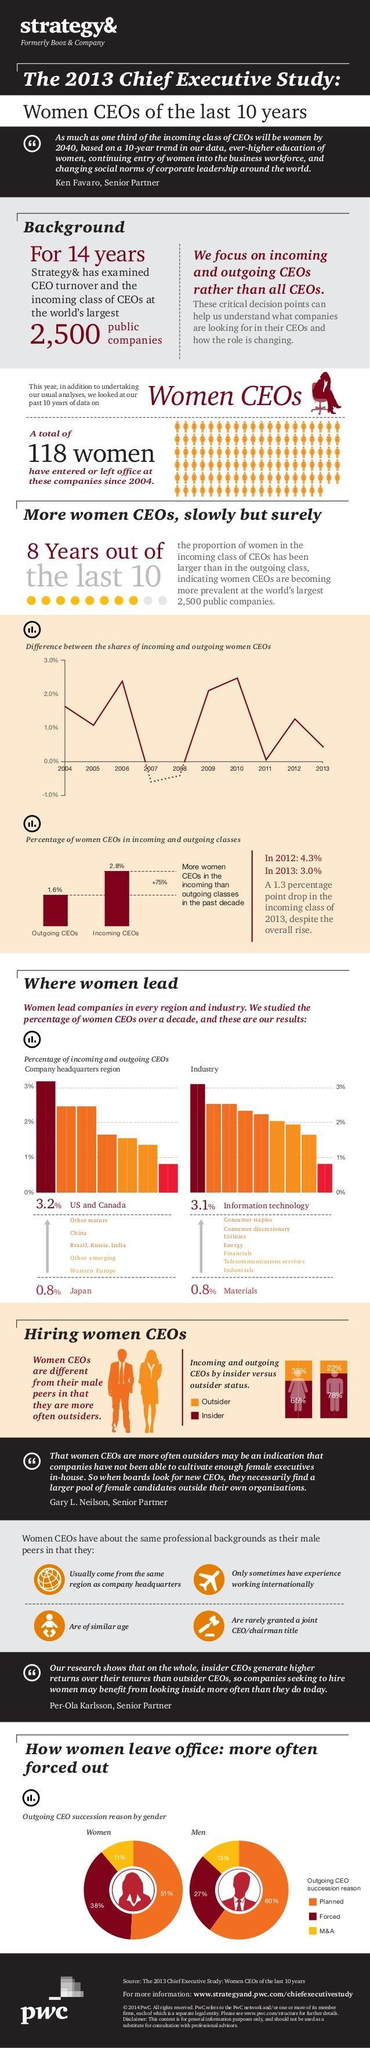What is the percentage of outgoing and incoming CEOs, taken together?
Answer the question with a short phrase. 4.4% 